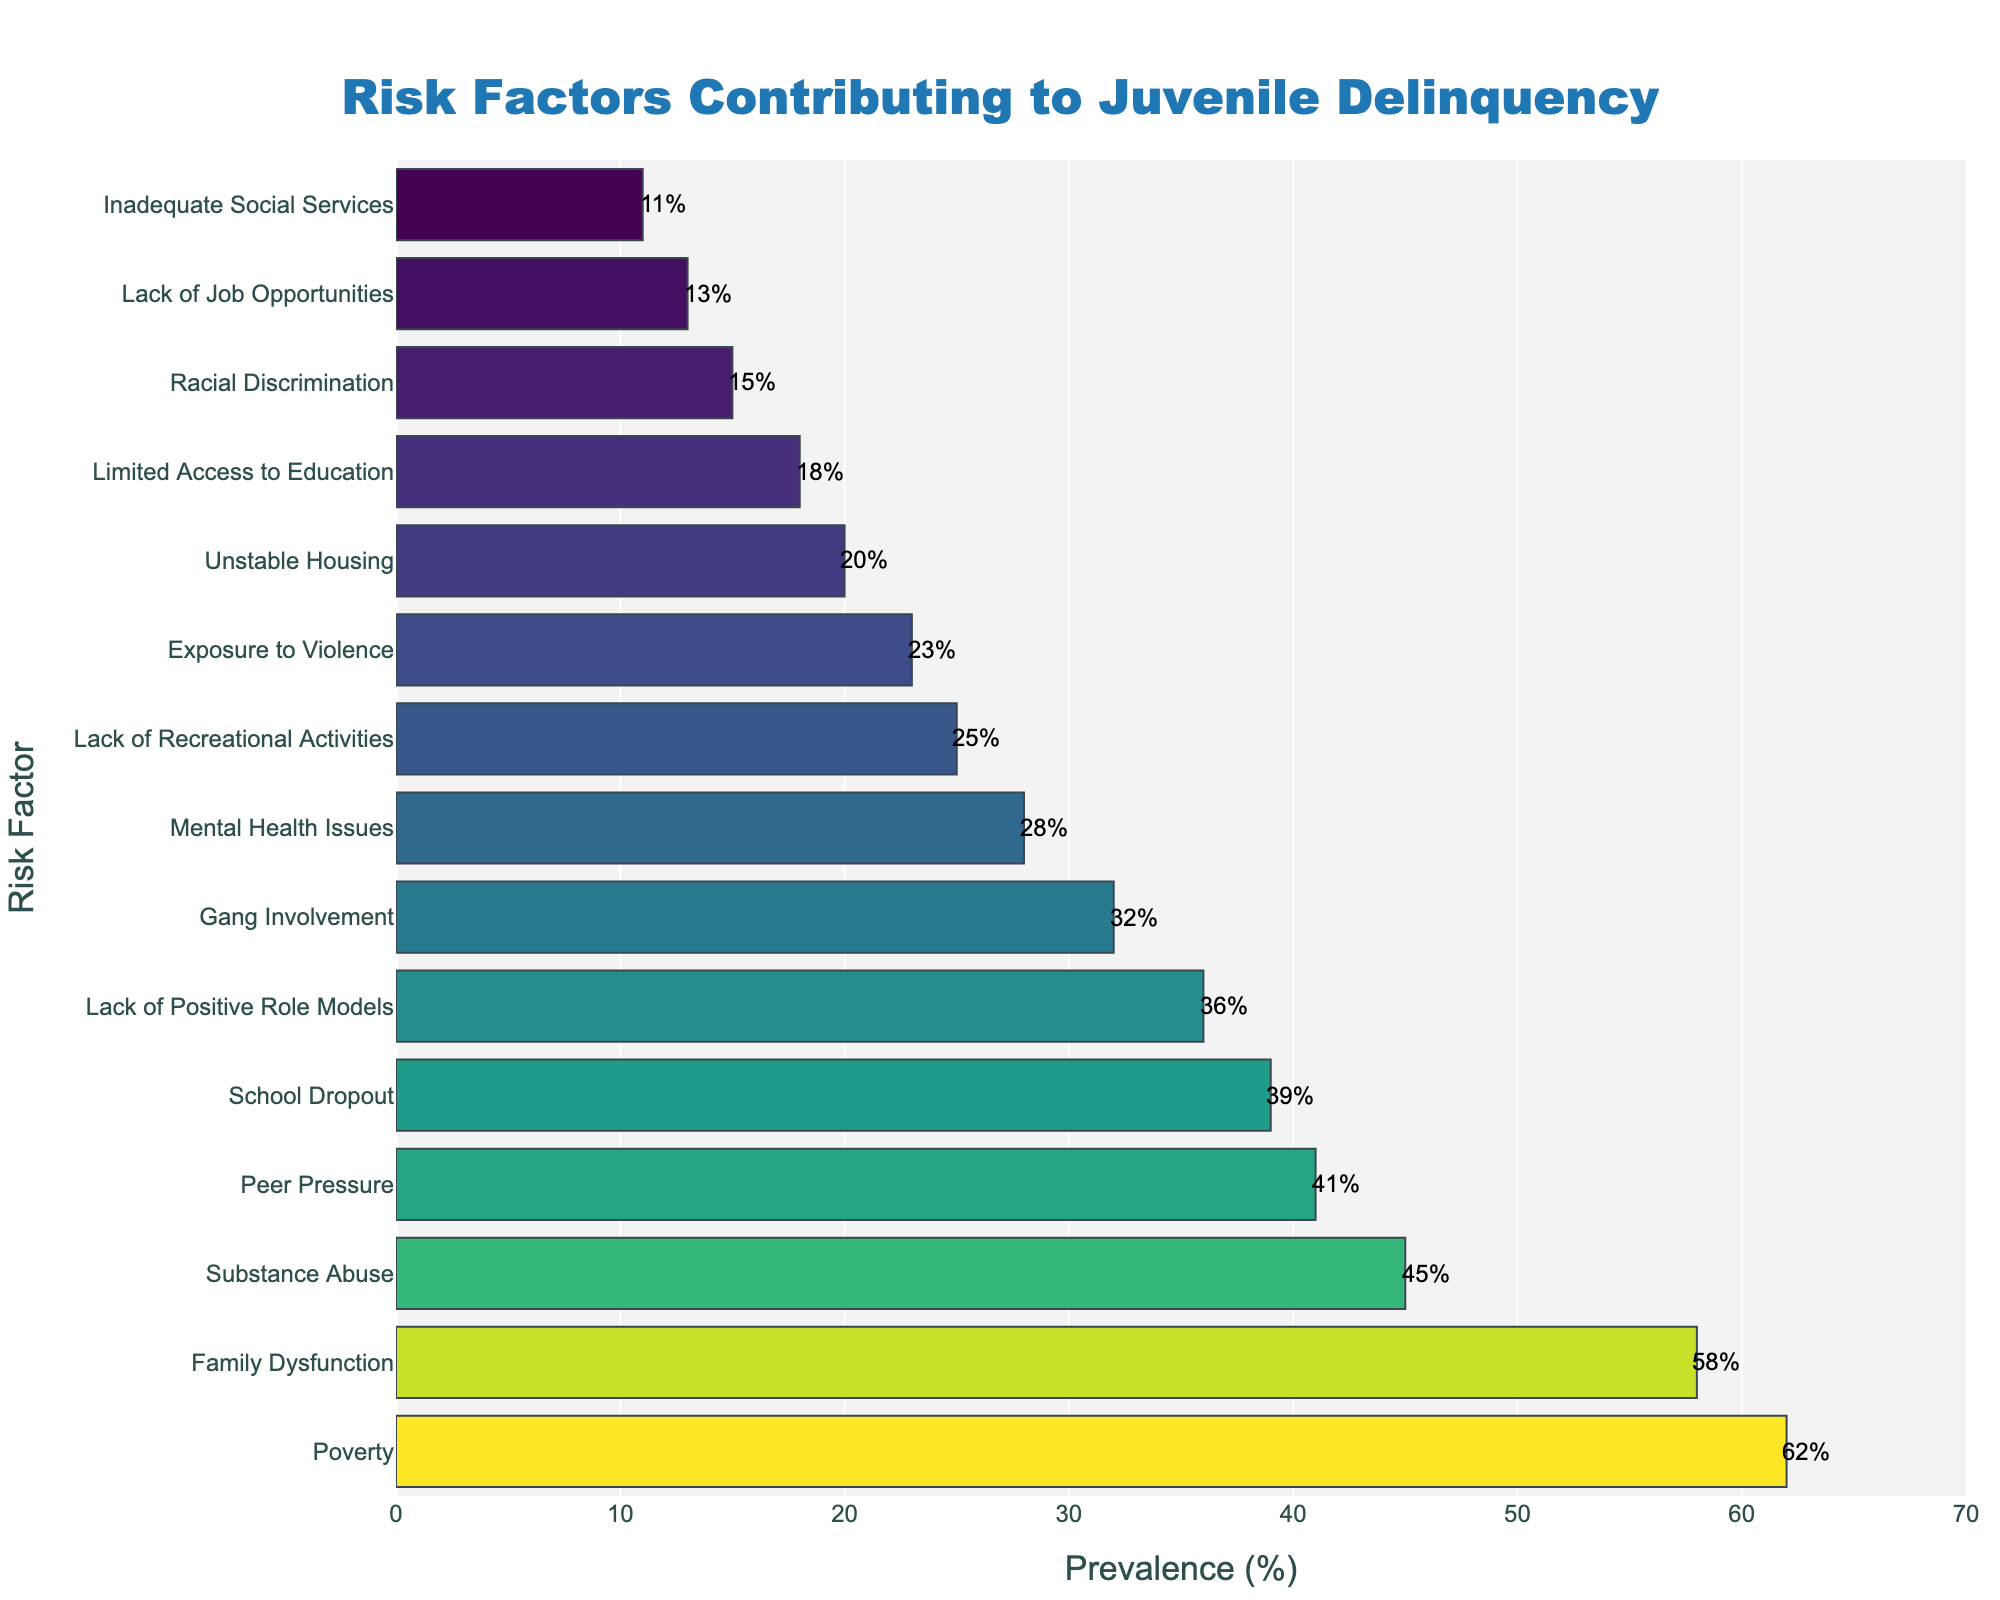What's the most prevalent risk factor contributing to juvenile delinquency in urban neighborhoods? The bar chart shows that the risk factor with the highest prevalence percentage is at the top of the sorted list and has the longest bar. The risk factor "Poverty" has the highest prevalence at 62%.
Answer: Poverty What risk factor has a prevalence of 32%? By reading the bar length and the labels, we can see that "Gang Involvement" has a prevalence of 32%.
Answer: Gang Involvement Which risk factor has the least prevalence? The bar at the bottom of the chart represents the risk factor with the lowest prevalence percentage. This is "Inadequate Social Services" at 11%.
Answer: Inadequate Social Services What is the difference in prevalence between Peer Pressure and Substance Abuse? Peer Pressure has a prevalence of 41%, while Substance Abuse has 45%. The difference is 45% - 41% = 4%.
Answer: 4% Which has a higher prevalence, Lack of Job Opportunities or Limited Access to Education? The bar for Limited Access to Education is higher (18%) compared to Lack of Job Opportunities (13%).
Answer: Limited Access to Education What is the average prevalence of the top five risk factors? The top five risk factors are Poverty (62%), Family Dysfunction (58%), Substance Abuse (45%), Peer Pressure (41%), and School Dropout (39%). The average is (62 + 58 + 45 + 41 + 39) / 5 = 49%.
Answer: 49% How does the prevalence of Family Dysfunction compare to Exposure to Violence? Family Dysfunction has a higher prevalence (58%) compared to Exposure to Violence (23%).
Answer: Family Dysfunction What's the combined prevalence of the three least prevalent risk factors? The three least prevalent risk factors are Inadequate Social Services (11%), Lack of Job Opportunities (13%), and Racial Discrimination (15%). The combined prevalence is 11% + 13% + 15% = 39%.
Answer: 39% What is the median prevalence value for all the risk factors listed? Arranging the prevalence percentages in ascending order: 11%, 13%, 15%, 18%, 20%, 23%, 25%, 28%, 32%, 36%, 39%, 41%, 45%, 58%, 62%. With 15 values, the median is the 8th value, which is 28%.
Answer: 28% Is there a risk factor with less than 20% prevalence? The chart shows that Unstable Housing (20%), Limited Access to Education (18%), Racial Discrimination (15%), Lack of Job Opportunities (13%), and Inadequate Social Services (11%) all have less than 20% prevalence.
Answer: Yes, there are 5 such factors 